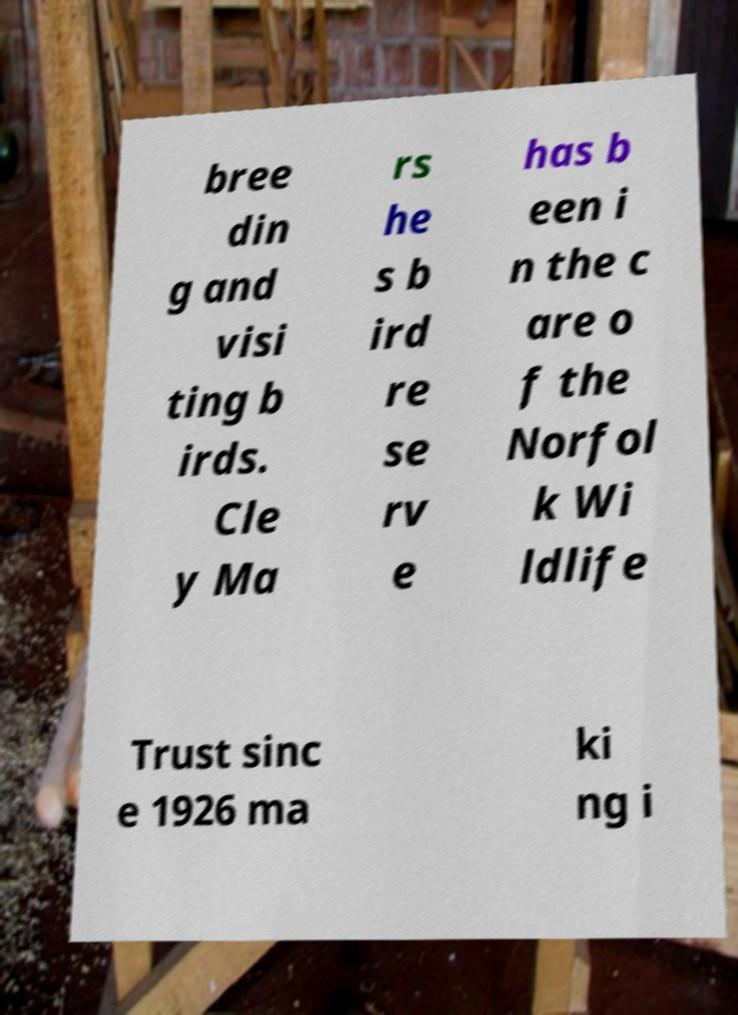I need the written content from this picture converted into text. Can you do that? bree din g and visi ting b irds. Cle y Ma rs he s b ird re se rv e has b een i n the c are o f the Norfol k Wi ldlife Trust sinc e 1926 ma ki ng i 